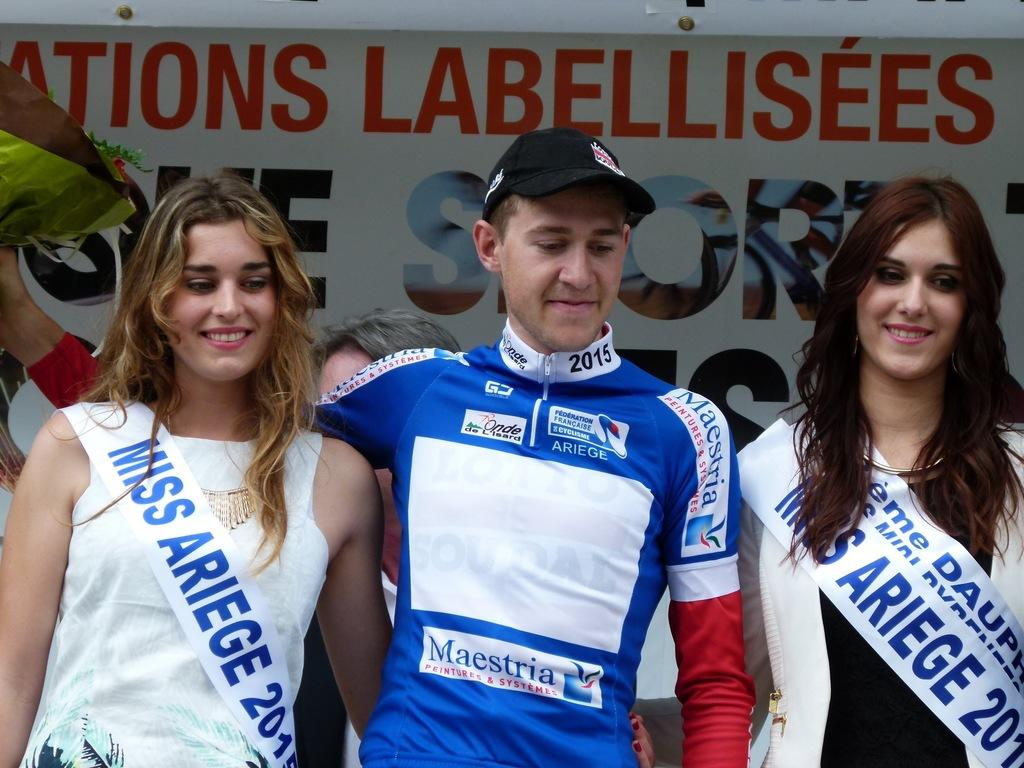<image>
Create a compact narrative representing the image presented. The racer celebrates with two former Miss Ariege 